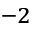Convert formula to latex. <formula><loc_0><loc_0><loc_500><loc_500>^ { - 2 }</formula> 